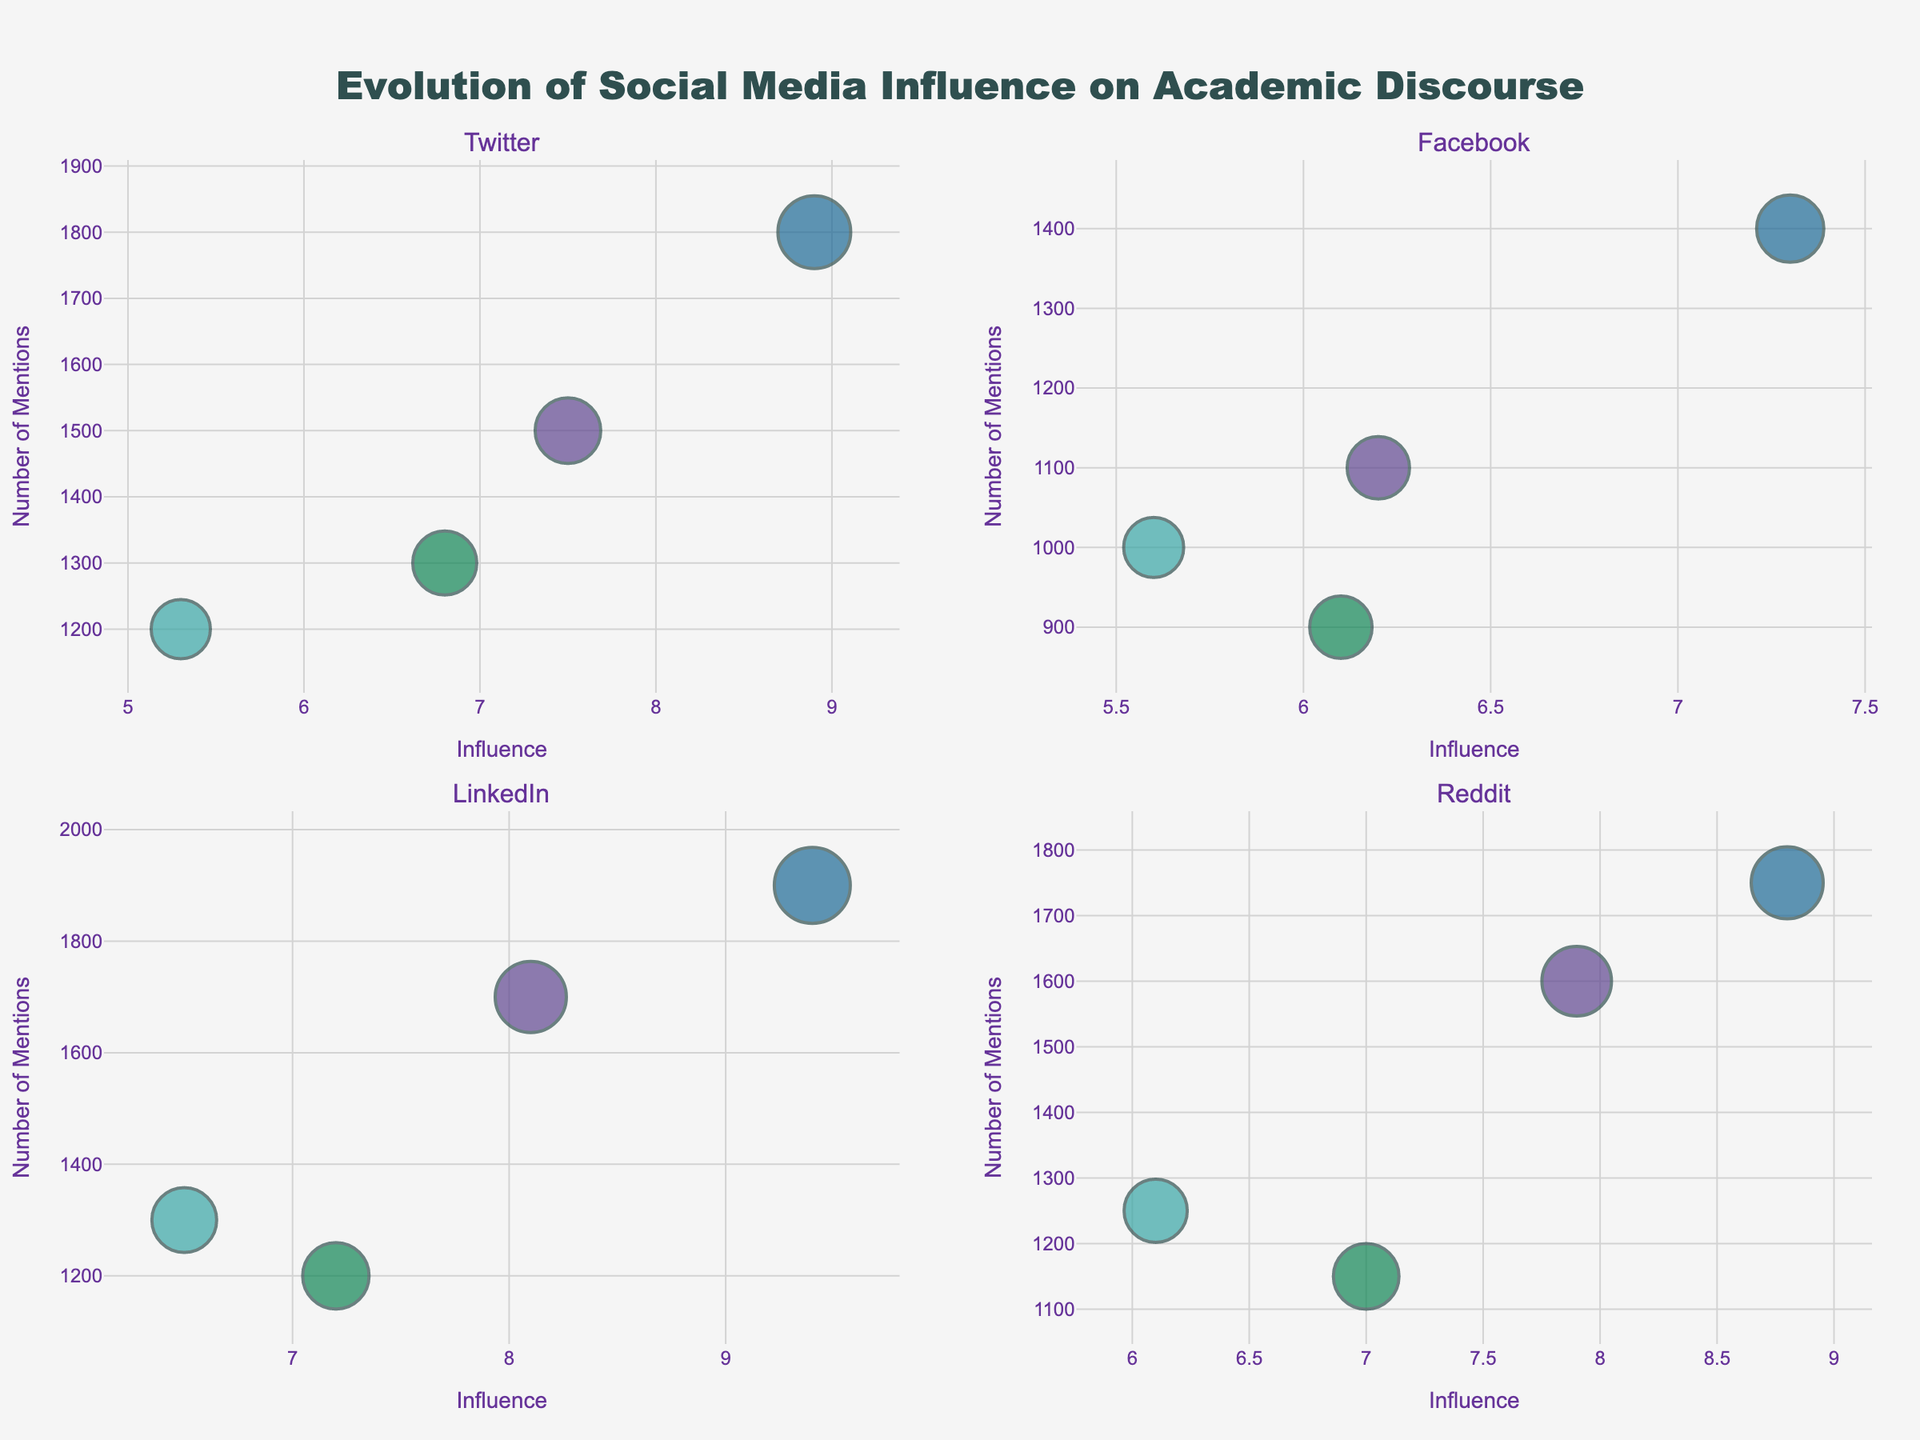What platform has the highest bubble size for the topic "Artificial Intelligence"? Look at the subplot corresponding to LinkedIn, identify the bubble with the highest size, which is a proxy for the Impact Factor.
Answer: LinkedIn Which platform shows the greatest Influence for the topic "Climate Change"? Identify the subplot that shows the highest Influence axis value for the Climate Change bubble.
Answer: LinkedIn How many platforms have a topic bubble exceeding an Influence value of 8.0? Count the number of subplots where there are bubbles for which Influence is greater than 8.0.
Answer: 3 platforms For the topic "Space Exploration," which platform has the highest Number of Mentions? Identify the subplot with the Space Exploration bubble and the highest Number of Mentions axis value.
Answer: Twitter What is the general trend of Impact Factors for the topic "Vaccination" across all platforms? Examine each subplot for the size of bubbles corresponding to Vaccination to compare their relative sizes.
Answer: Lower than other topics Which topic has the largest bubble size on Reddit, indicating the highest Impact Factor? Look at the Reddit subplot and identify the topic with the largest bubble.
Answer: Artificial Intelligence How does the Influence of "Vaccination" on Facebook compare to its Influence on LinkedIn? Compare the Influence axis values of the Vaccination bubble between Facebook and LinkedIn subplots.
Answer: Lower on Facebook Which platform has the smallest bubble for "Space Exploration," indicating the lowest Impact Factor? Identify the subplot with the smallest bubble for Space Exploration as a proxy for the lowest Impact Factor.
Answer: Facebook Are there any platforms where the Influence of "Artificial Intelligence" exceeds 9.0? If so, which ones? Check all subplots for bubbles corresponding to Artificial Intelligence with Influence values exceeding 9.0.
Answer: LinkedIn 